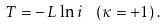<formula> <loc_0><loc_0><loc_500><loc_500>T = - \, L \, \ln i \text { } \, \left ( \kappa = + 1 \right ) .</formula> 